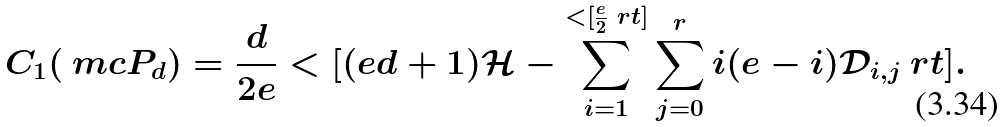Convert formula to latex. <formula><loc_0><loc_0><loc_500><loc_500>C _ { 1 } ( \ m c { P } _ { d } ) = \frac { d } { 2 e } < [ ( e d + 1 ) \mathcal { H } - \sum _ { i = 1 } ^ { < [ \frac { e } { 2 } \ r t ] } \sum _ { j = 0 } ^ { r } i ( e - i ) \mathcal { D } _ { i , j } \ r t ] .</formula> 